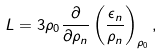<formula> <loc_0><loc_0><loc_500><loc_500>L = 3 \rho _ { 0 } \frac { \partial } { \partial \rho _ { n } } \left ( \frac { \epsilon _ { n } } { \rho _ { n } } \right ) _ { \rho _ { 0 } } ,</formula> 